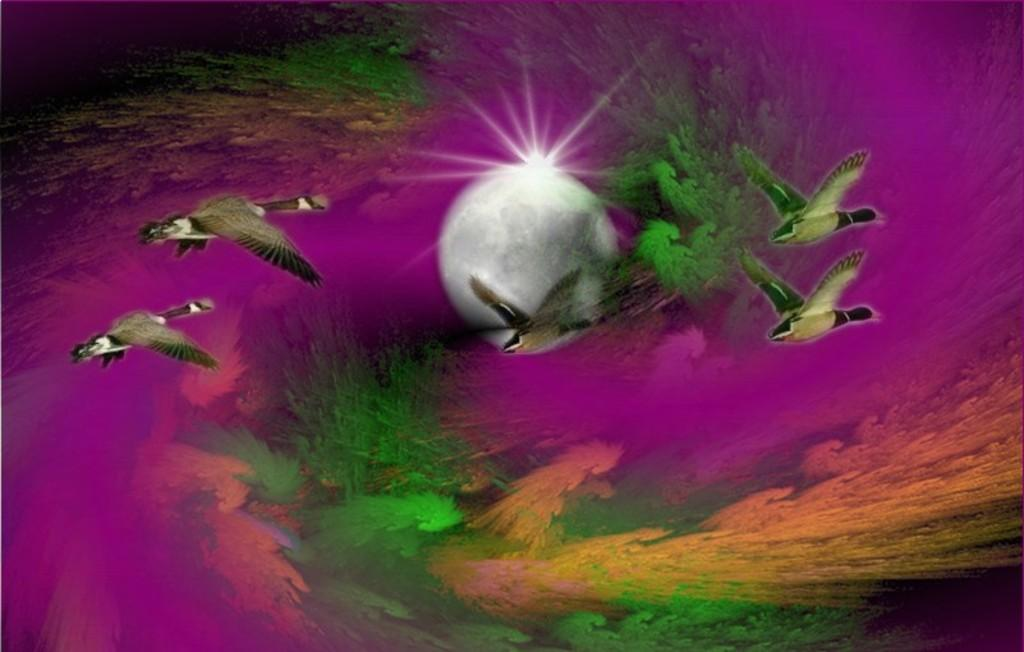What is happening in the image involving animals? There are birds flying in the image. What celestial body can be seen in the image? The moon is visible in the image. How would you describe the background of the image? The background of the image has different colors. How many kittens are playing with the paint in the image? There are no kittens or paint present in the image. What type of fold can be seen in the birds' wings in the image? There are no folds visible in the birds' wings in the image, as they are flying. 